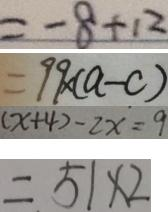Convert formula to latex. <formula><loc_0><loc_0><loc_500><loc_500>= - 8 + 1 2 
 = 9 9 \times ( a - c ) 
 ( x + 4 ) - 2 x = 9 
 = 5 1 \times 2</formula> 